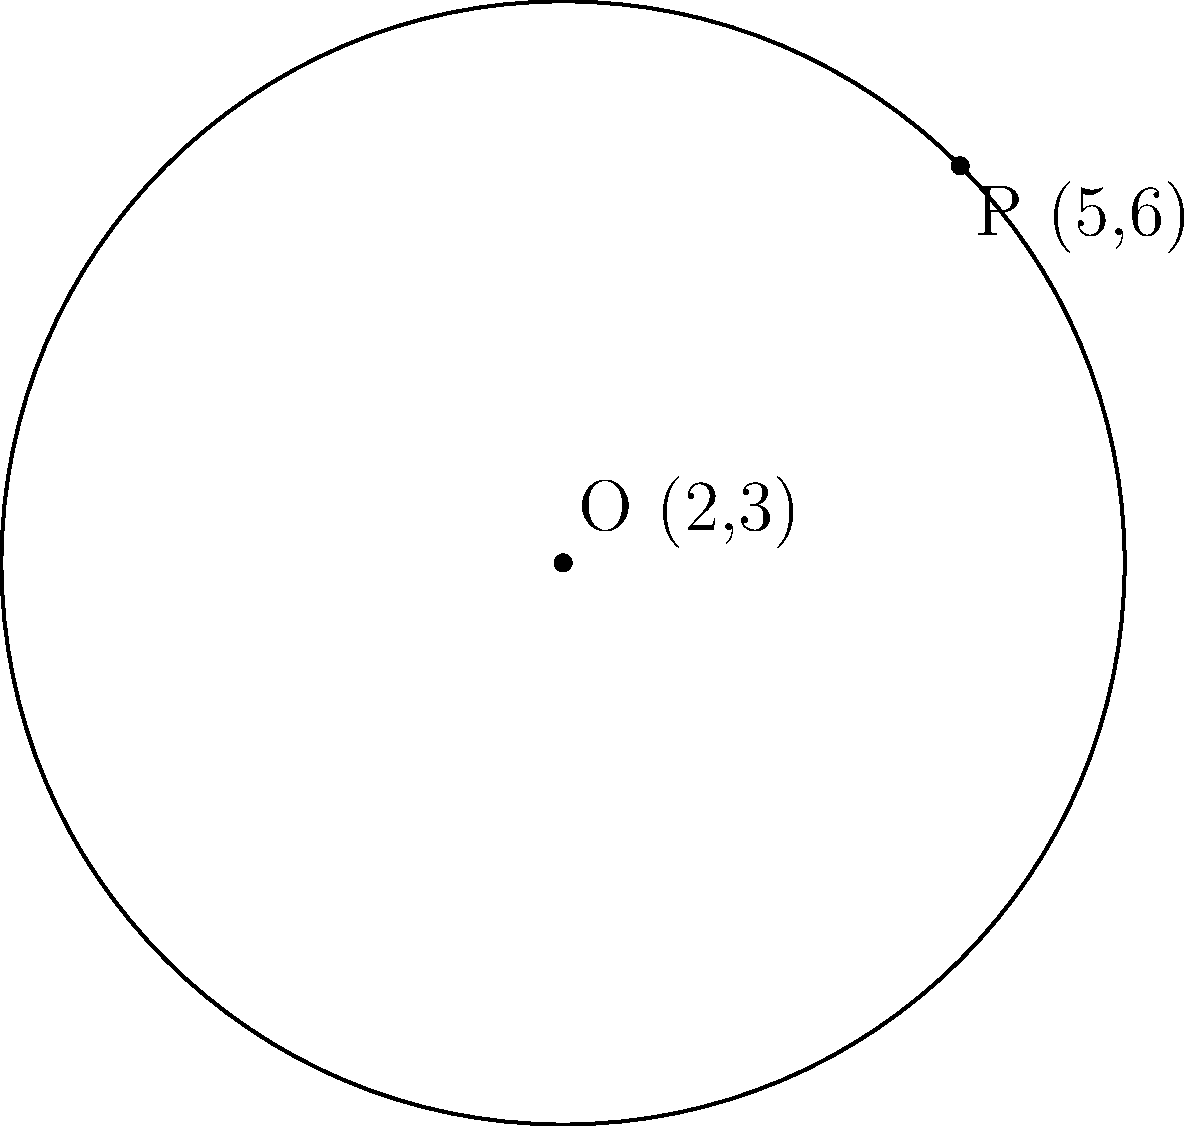Faithful the Boston terrier is learning about circles in his Sunday school geometry class. He's given a circle with center O at (2,3) and a point P on its circumference at (5,6). What is the equation of this circle, which Faithful calls "Faithful's Circle"? Let's help Faithful solve this step-by-step:

1) The general equation of a circle is $$(x-h)^2 + (y-k)^2 = r^2$$
   where (h,k) is the center and r is the radius.

2) We know the center O is at (2,3), so h = 2 and k = 3.

3) To find r, we need to calculate the distance between O(2,3) and P(5,6):
   $$r^2 = (x_P - x_O)^2 + (y_P - y_O)^2$$
   $$r^2 = (5 - 2)^2 + (6 - 3)^2$$
   $$r^2 = 3^2 + 3^2 = 9 + 9 = 18$$

4) Now we can write the equation:
   $$(x-2)^2 + (y-3)^2 = 18$$

5) This is the equation of Faithful's Circle in standard form.

Faithful can remember this as the circle of blessings, with 18 representing the sum of God's completeness (3) multiplied by man's imperfection (6).
Answer: $$(x-2)^2 + (y-3)^2 = 18$$ 